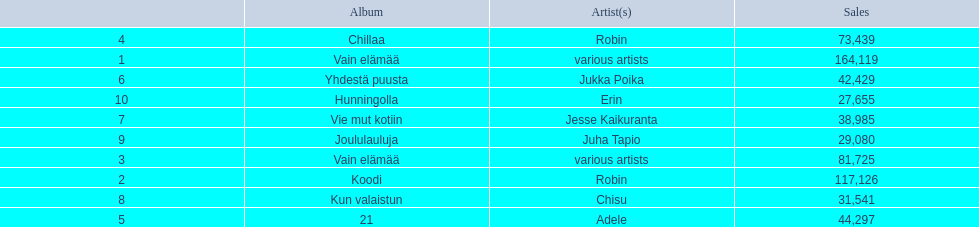Parse the full table. {'header': ['', 'Album', 'Artist(s)', 'Sales'], 'rows': [['4', 'Chillaa', 'Robin', '73,439'], ['1', 'Vain elämää', 'various artists', '164,119'], ['6', 'Yhdestä puusta', 'Jukka Poika', '42,429'], ['10', 'Hunningolla', 'Erin', '27,655'], ['7', 'Vie mut kotiin', 'Jesse Kaikuranta', '38,985'], ['9', 'Joululauluja', 'Juha Tapio', '29,080'], ['3', 'Vain elämää', 'various artists', '81,725'], ['2', 'Koodi', 'Robin', '117,126'], ['8', 'Kun valaistun', 'Chisu', '31,541'], ['5', '21', 'Adele', '44,297']]} Which was the last album to sell over 100,000 records? Koodi. 